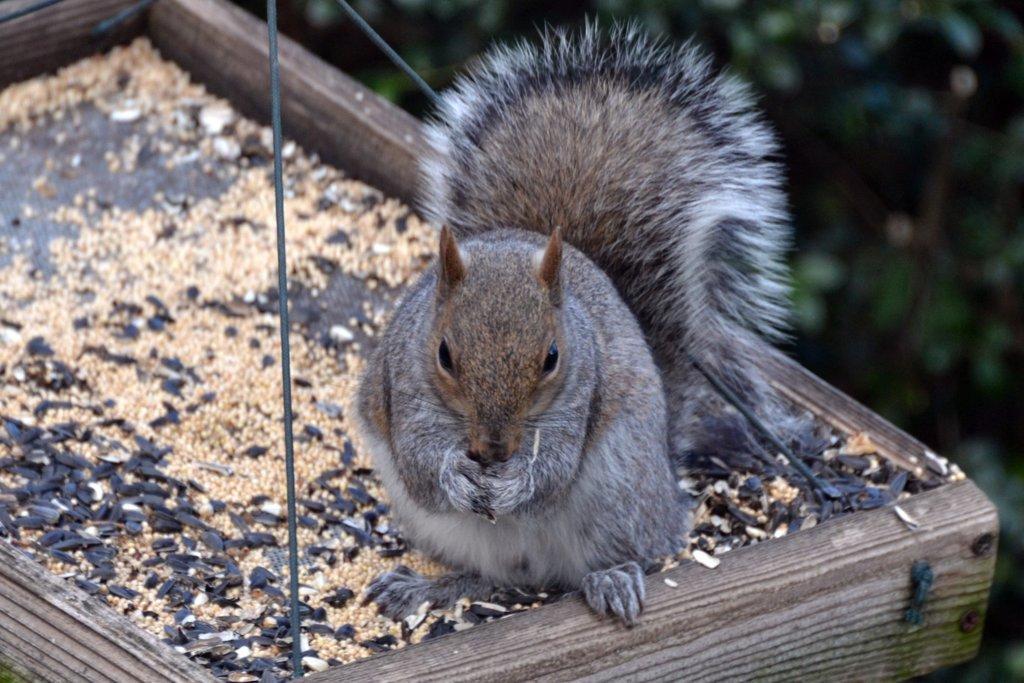Could you give a brief overview of what you see in this image? At the bottom of the image there is a swing, on the swing there is a squirrel. Background of the image is blur. 